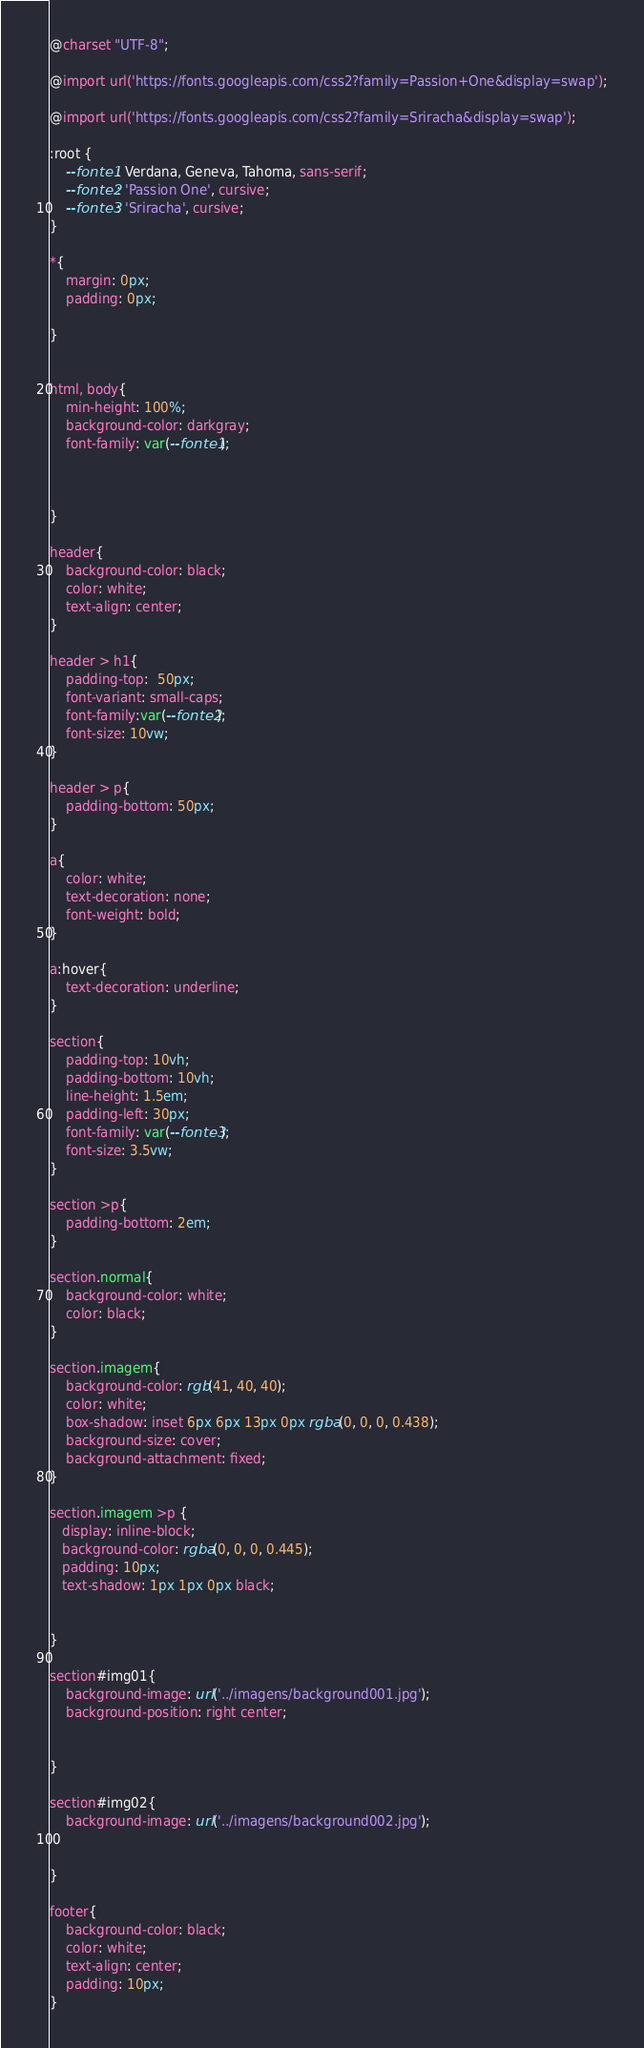<code> <loc_0><loc_0><loc_500><loc_500><_CSS_>@charset "UTF-8";

@import url('https://fonts.googleapis.com/css2?family=Passion+One&display=swap');

@import url('https://fonts.googleapis.com/css2?family=Sriracha&display=swap');

:root {
    --fonte1: Verdana, Geneva, Tahoma, sans-serif;
    --fonte2: 'Passion One', cursive;
    --fonte3: 'Sriracha', cursive;
}

*{
    margin: 0px;
    padding: 0px;

}
   

html, body{
    min-height: 100%;
    background-color: darkgray;
    font-family: var(--fonte1);
   
    
    
}

header{
    background-color: black;
    color: white;
    text-align: center;
}

header > h1{
    padding-top:  50px;
    font-variant: small-caps;
    font-family:var(--fonte2);
    font-size: 10vw;
}

header > p{
    padding-bottom: 50px;
}

a{
    color: white;
    text-decoration: none;
    font-weight: bold;
}

a:hover{
    text-decoration: underline;
}

section{
    padding-top: 10vh;
    padding-bottom: 10vh;
    line-height: 1.5em;
    padding-left: 30px;
    font-family: var(--fonte3);
    font-size: 3.5vw;
}

section >p{
    padding-bottom: 2em;
}

section.normal{
    background-color: white;
    color: black;
}

section.imagem{
    background-color: rgb(41, 40, 40);
    color: white;
    box-shadow: inset 6px 6px 13px 0px rgba(0, 0, 0, 0.438);
    background-size: cover;
    background-attachment: fixed;
}

section.imagem >p {
   display: inline-block;
   background-color: rgba(0, 0, 0, 0.445);
   padding: 10px;
   text-shadow: 1px 1px 0px black;
  

}

section#img01{
    background-image: url('../imagens/background001.jpg');
    background-position: right center;
    

}

section#img02{
    background-image: url('../imagens/background002.jpg');
   

}

footer{
    background-color: black;
    color: white;
    text-align: center;
    padding: 10px;
}</code> 